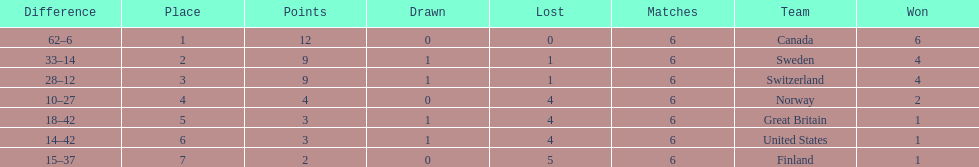What team placed after canada? Sweden. 